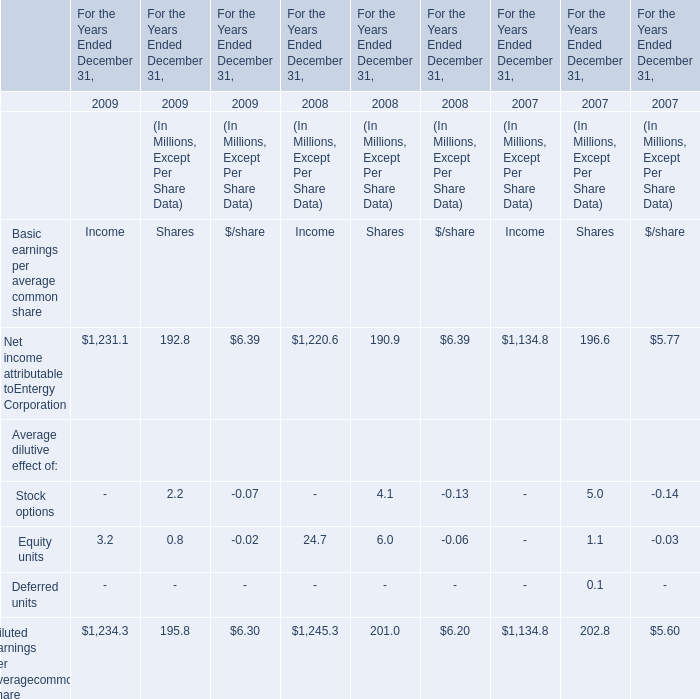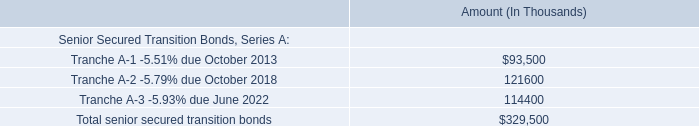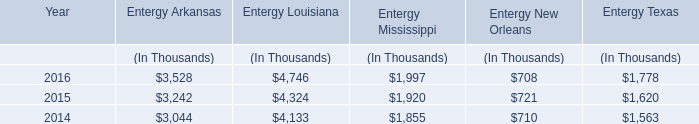what is the total expected payments on the bonds for the next 5 years for entergy new orleans storm recovery funding? 
Computations: ((((10.6 + 11) + 11.2) + 11.6) + 11.9)
Answer: 56.3. 